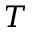<formula> <loc_0><loc_0><loc_500><loc_500>T</formula> 